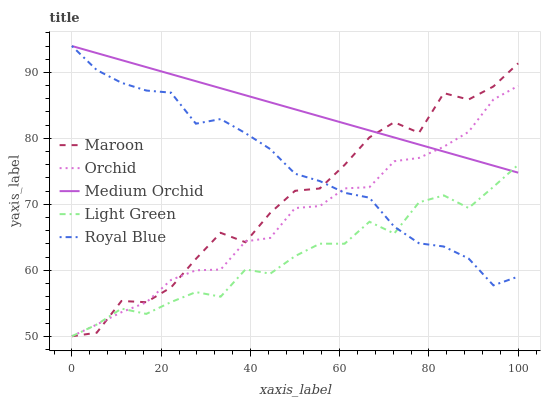Does Medium Orchid have the minimum area under the curve?
Answer yes or no. No. Does Light Green have the maximum area under the curve?
Answer yes or no. No. Is Light Green the smoothest?
Answer yes or no. No. Is Light Green the roughest?
Answer yes or no. No. Does Medium Orchid have the lowest value?
Answer yes or no. No. Does Light Green have the highest value?
Answer yes or no. No. 